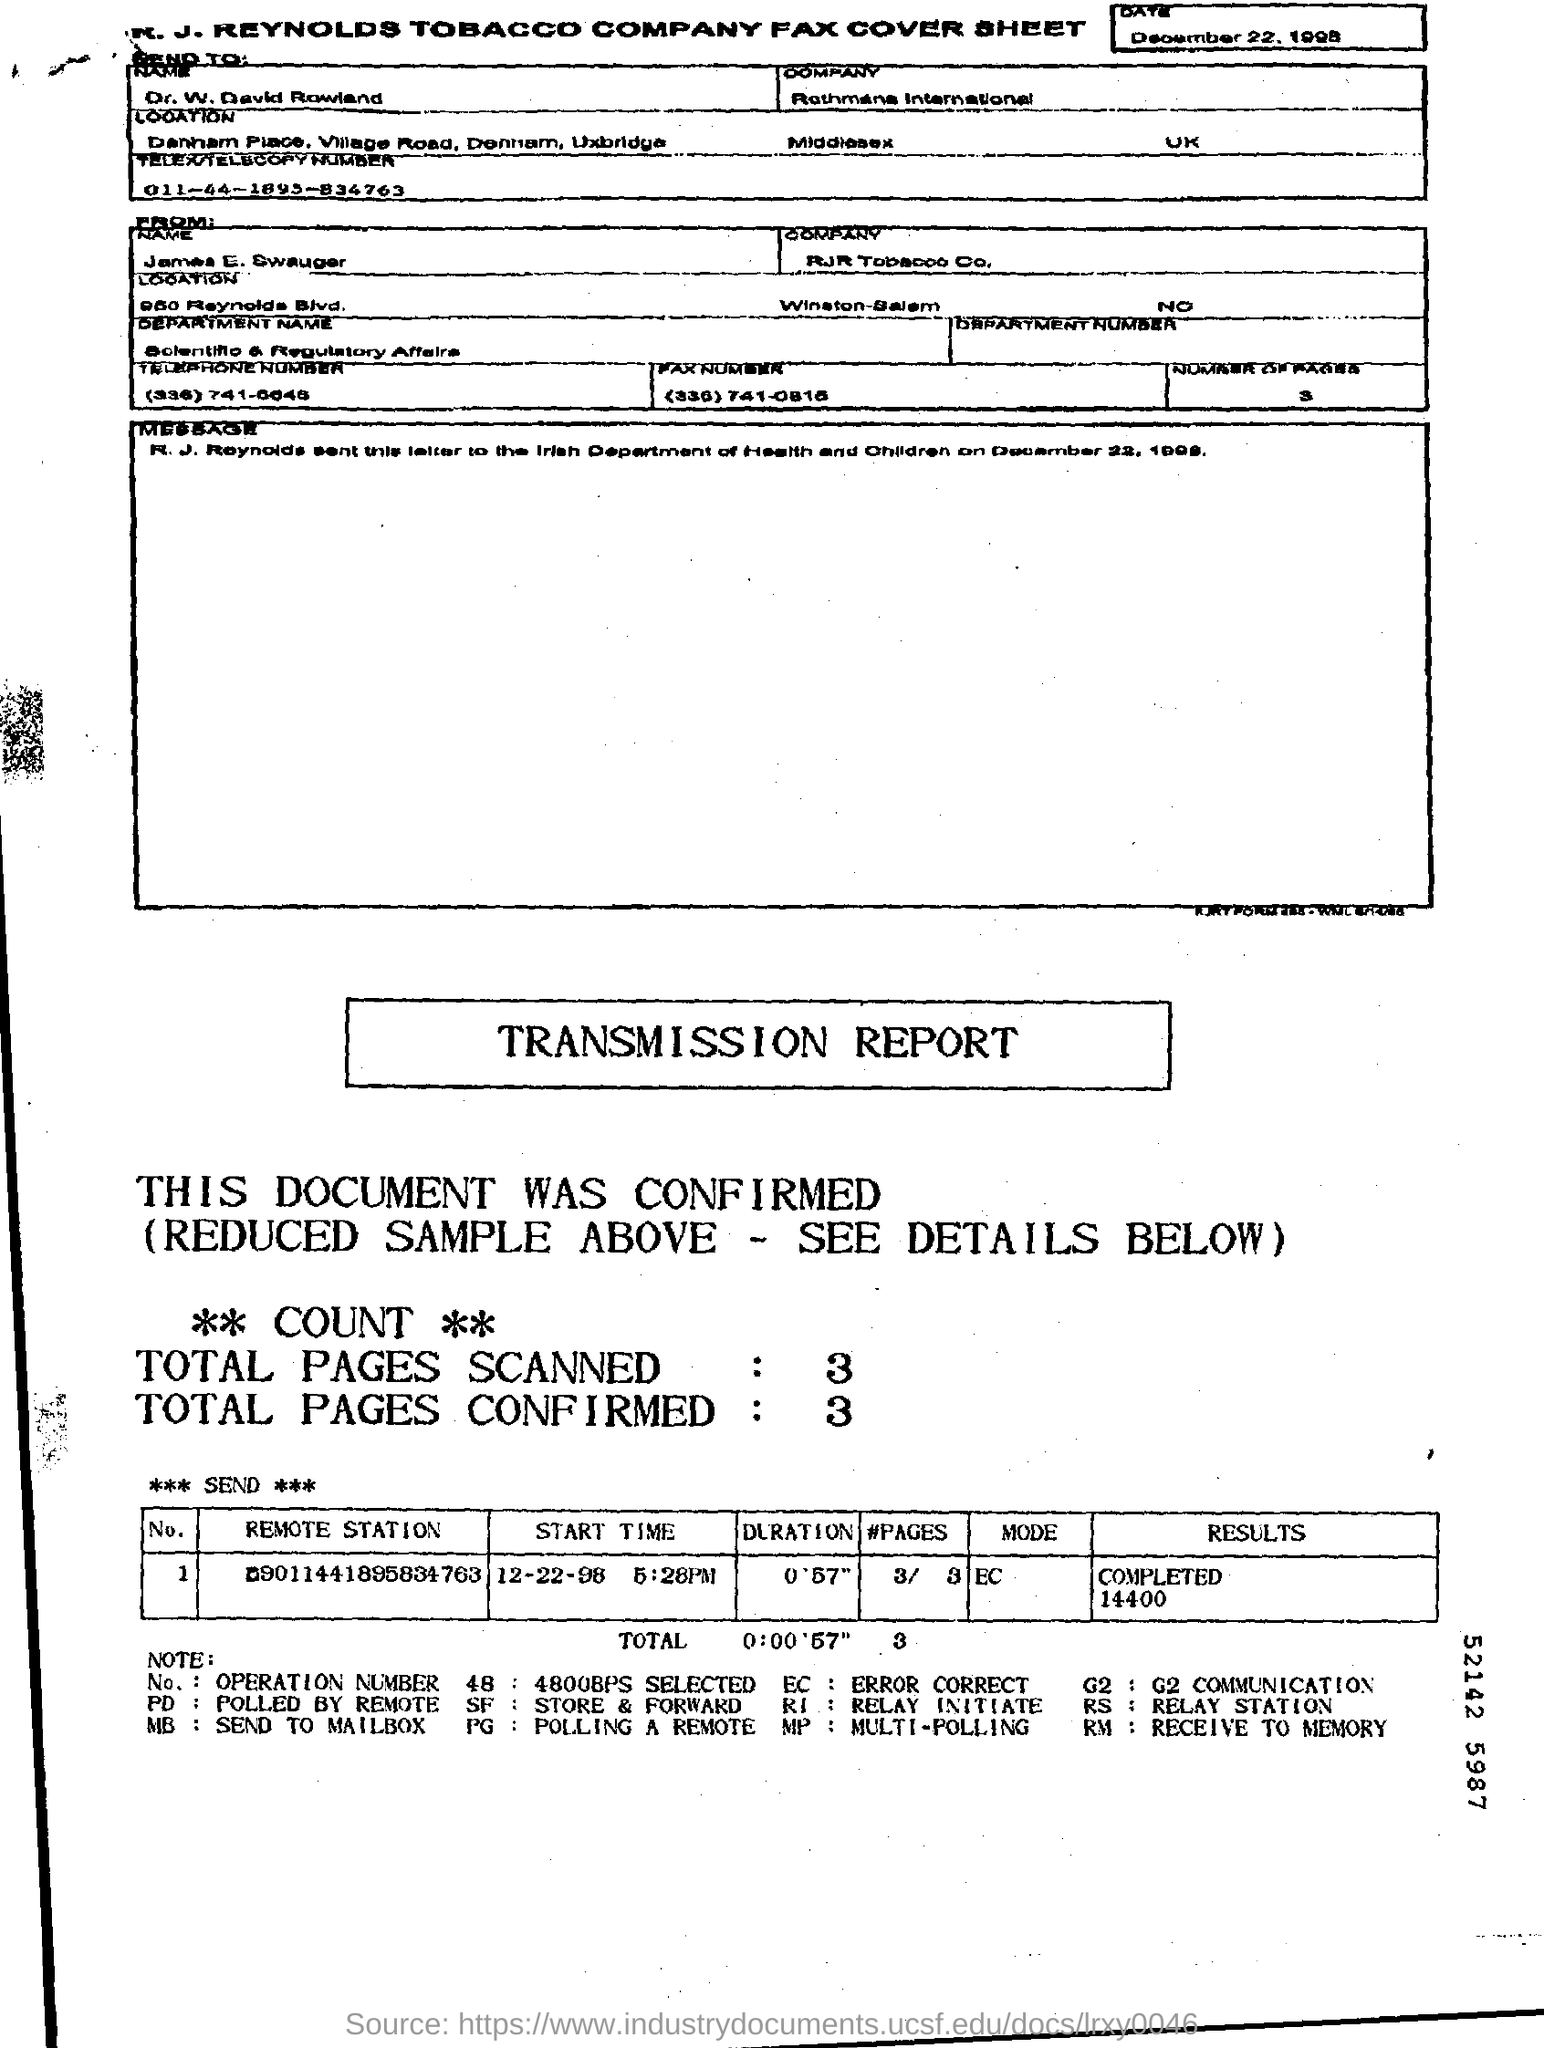To Whom is this Fax addressed to?
Your response must be concise. Dr. W. David Rowland. 